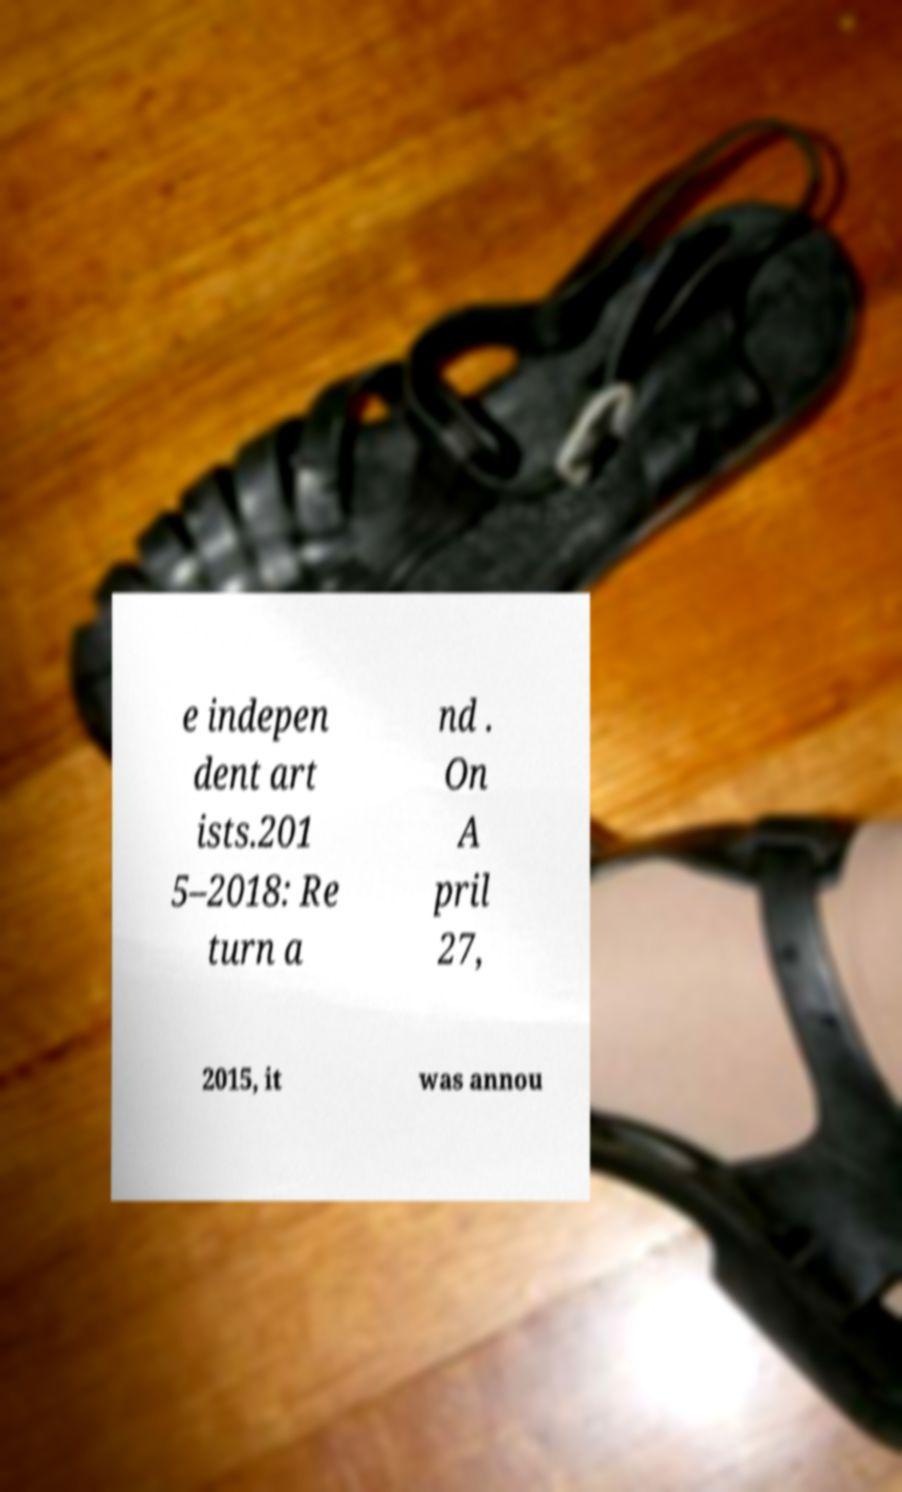Could you assist in decoding the text presented in this image and type it out clearly? e indepen dent art ists.201 5–2018: Re turn a nd . On A pril 27, 2015, it was annou 